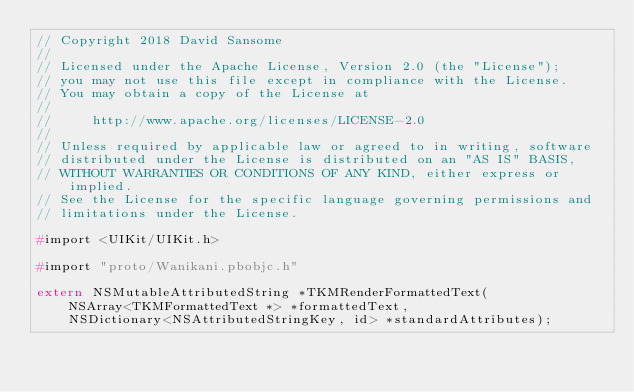<code> <loc_0><loc_0><loc_500><loc_500><_C_>// Copyright 2018 David Sansome
//
// Licensed under the Apache License, Version 2.0 (the "License");
// you may not use this file except in compliance with the License.
// You may obtain a copy of the License at
//
//     http://www.apache.org/licenses/LICENSE-2.0
//
// Unless required by applicable law or agreed to in writing, software
// distributed under the License is distributed on an "AS IS" BASIS,
// WITHOUT WARRANTIES OR CONDITIONS OF ANY KIND, either express or implied.
// See the License for the specific language governing permissions and
// limitations under the License.

#import <UIKit/UIKit.h>

#import "proto/Wanikani.pbobjc.h"

extern NSMutableAttributedString *TKMRenderFormattedText(
    NSArray<TKMFormattedText *> *formattedText,
    NSDictionary<NSAttributedStringKey, id> *standardAttributes);
</code> 